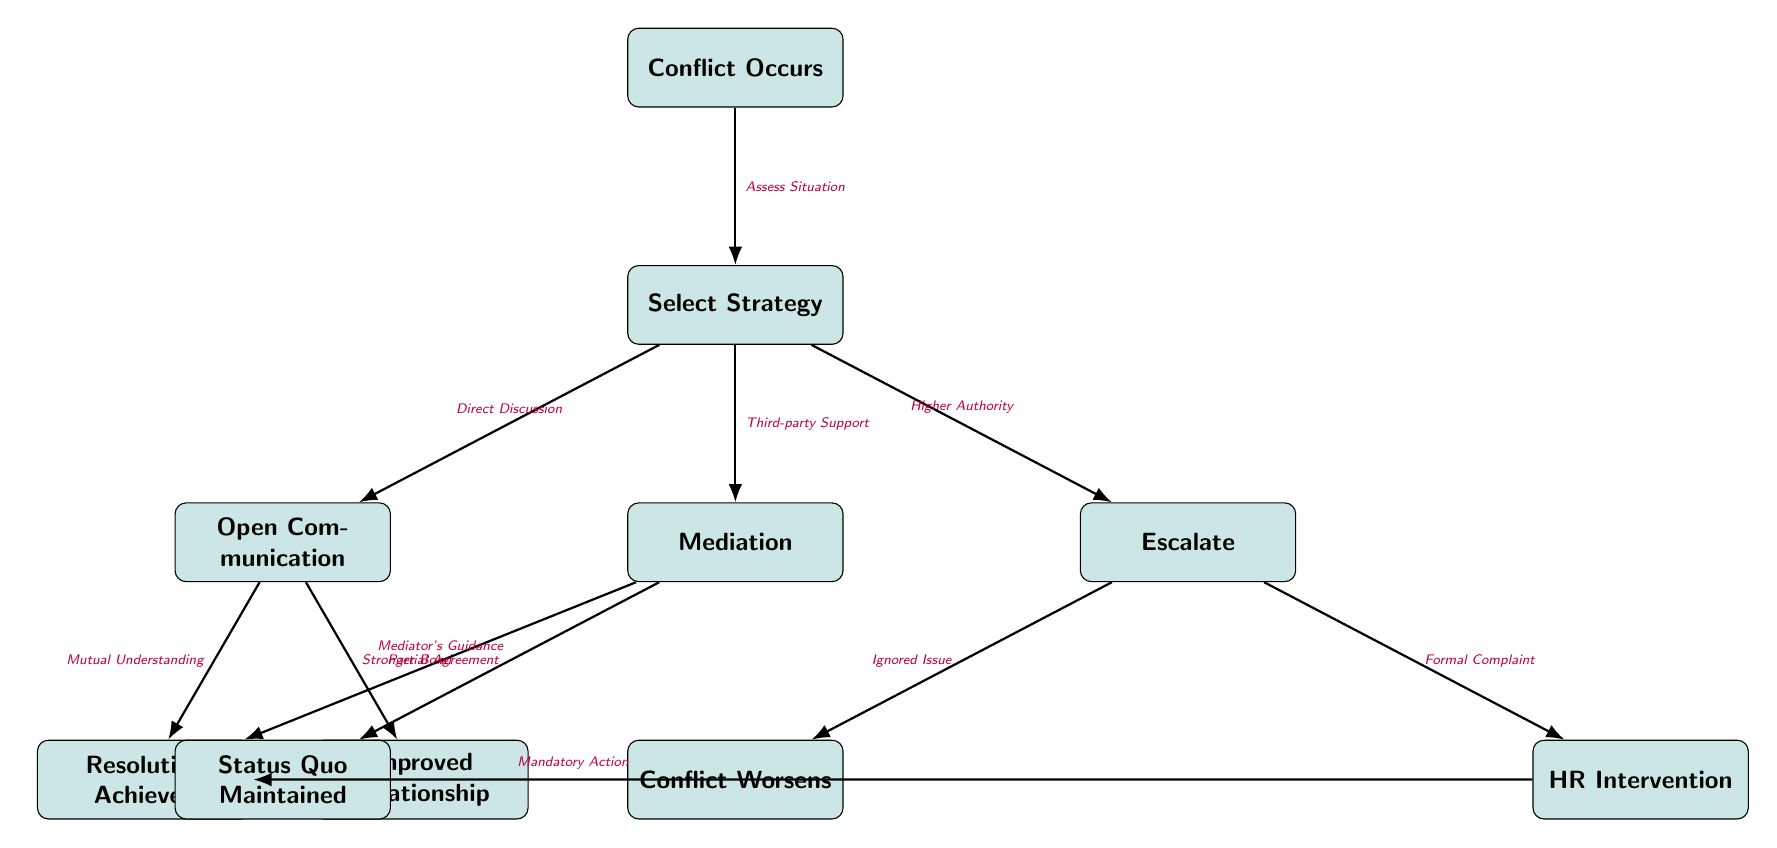What's the first node in the diagram? The first node in the diagram is where the process begins, which is labeled "Conflict Occurs." This node is visually positioned at the top of the diagram.
Answer: Conflict Occurs How many primary strategies are listed for conflict resolution? The diagram explicitly lists three primary strategies shown as nodes connected to "Select Strategy." These strategies are "Open Communication," "Mediation," and "Escalate."
Answer: 3 What is the outcome of choosing "Open Communication"? The diagram illustrates two direct outcomes stemming from the "Open Communication" node. They are "Resolution Achieved" and "Improved Relationship."
Answer: Resolution Achieved, Improved Relationship Which action follows "Escalate"? After choosing "Escalate" as the strategy, there are two possible outcomes depicted. The actions that follow are "Conflict Worsens" and "HR Intervention," which are directly connected to the "Escalate" node.
Answer: Conflict Worsens, HR Intervention What is the relationship between "Mediation" and its outcomes? The "Mediation" node has two outcomes: "Resolution Achieved" is a positive result facilitated by "Mediator's Guidance," while "Status Quo Maintained" indicates a lesser outcome, representing a partial resolution. This connection shows that mediation can lead to either successful resolution or simply maintaining the existing situation.
Answer: Resolution Achieved, Status Quo Maintained If HR Intervention occurs, what is its mandatory consequence? The diagram shows a direct connection from "HR Intervention" to "Resolution Achieved" through a process termed "Mandatory Action." This indicates that HR intervention leads directly to the resolution of the conflict.
Answer: Resolution Achieved What does "Conflict Occurs" lead to? The "Conflict Occurs" node is the starting point and leads directly to the "Select Strategy" node, indicating that after a conflict, a strategy must be chosen to resolve it. This reflects the flow of how conflicts should be addressed in the office.
Answer: Select Strategy Which outcome indicates a negative escalation? The "Escalate" strategy can lead to "Conflict Worsens," which is the outcome that signifies a negative escalation in the conflict management process, highlighting that escalation can exacerbate the situation.
Answer: Conflict Worsens 